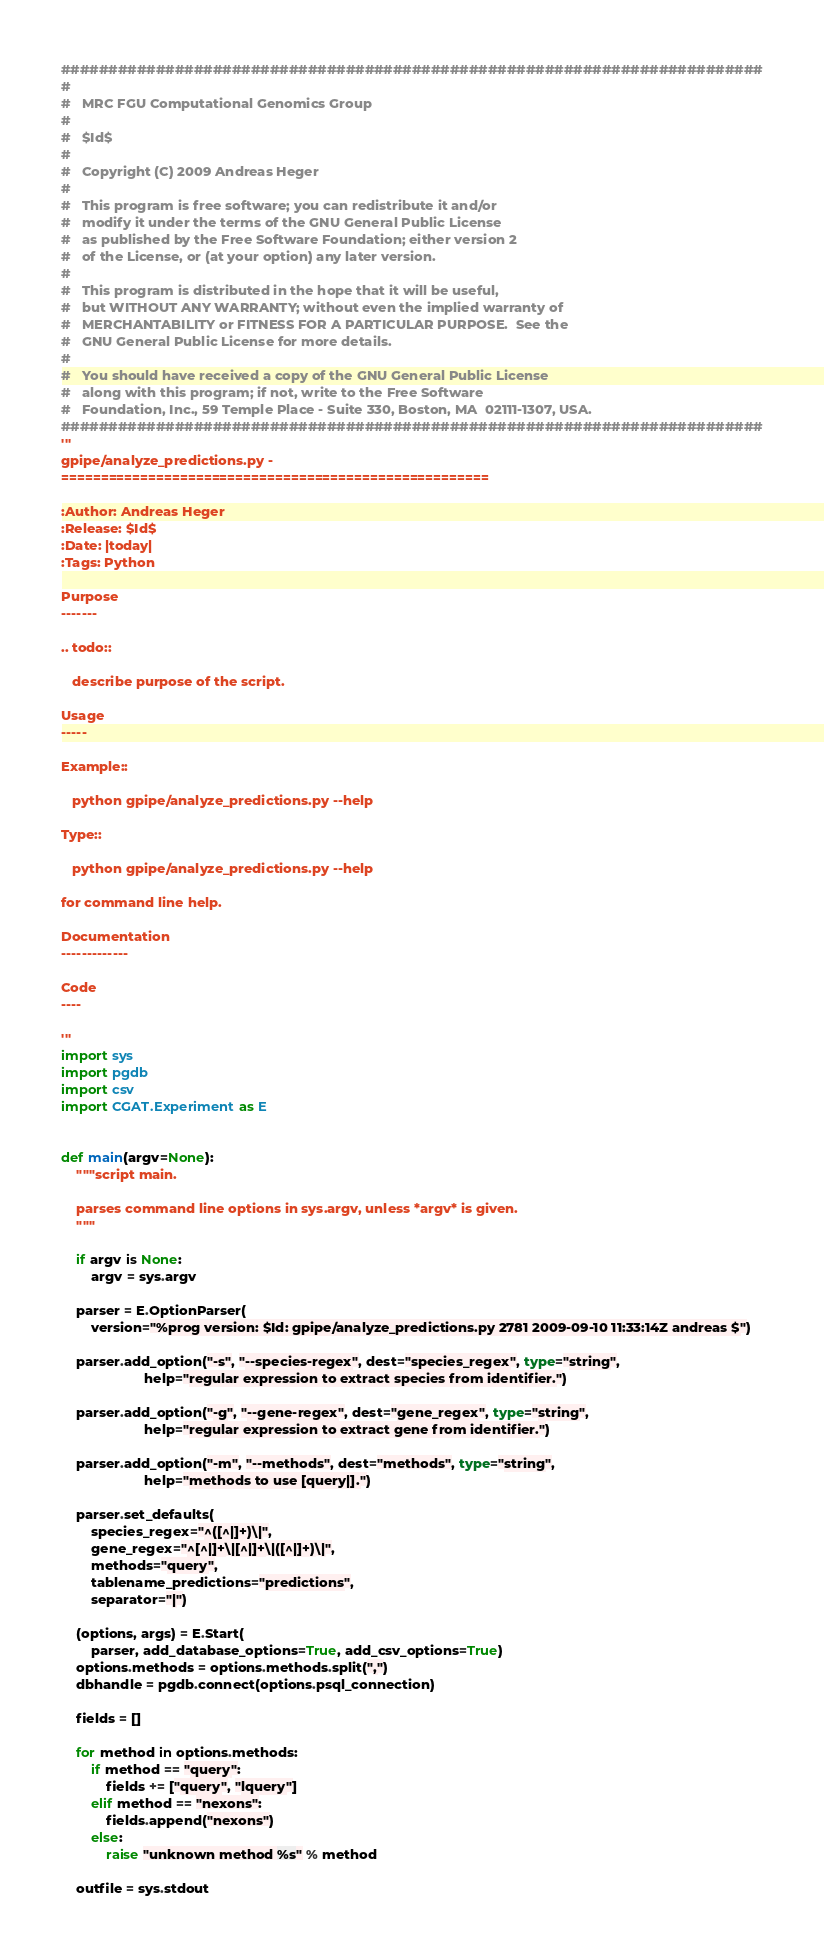<code> <loc_0><loc_0><loc_500><loc_500><_Python_>##########################################################################
#
#   MRC FGU Computational Genomics Group
#
#   $Id$
#
#   Copyright (C) 2009 Andreas Heger
#
#   This program is free software; you can redistribute it and/or
#   modify it under the terms of the GNU General Public License
#   as published by the Free Software Foundation; either version 2
#   of the License, or (at your option) any later version.
#
#   This program is distributed in the hope that it will be useful,
#   but WITHOUT ANY WARRANTY; without even the implied warranty of
#   MERCHANTABILITY or FITNESS FOR A PARTICULAR PURPOSE.  See the
#   GNU General Public License for more details.
#
#   You should have received a copy of the GNU General Public License
#   along with this program; if not, write to the Free Software
#   Foundation, Inc., 59 Temple Place - Suite 330, Boston, MA  02111-1307, USA.
##########################################################################
'''
gpipe/analyze_predictions.py - 
======================================================

:Author: Andreas Heger
:Release: $Id$
:Date: |today|
:Tags: Python

Purpose
-------

.. todo::
   
   describe purpose of the script.

Usage
-----

Example::

   python gpipe/analyze_predictions.py --help

Type::

   python gpipe/analyze_predictions.py --help

for command line help.

Documentation
-------------

Code
----

'''
import sys
import pgdb
import csv
import CGAT.Experiment as E


def main(argv=None):
    """script main.

    parses command line options in sys.argv, unless *argv* is given.
    """

    if argv is None:
        argv = sys.argv

    parser = E.OptionParser(
        version="%prog version: $Id: gpipe/analyze_predictions.py 2781 2009-09-10 11:33:14Z andreas $")

    parser.add_option("-s", "--species-regex", dest="species_regex", type="string",
                      help="regular expression to extract species from identifier.")

    parser.add_option("-g", "--gene-regex", dest="gene_regex", type="string",
                      help="regular expression to extract gene from identifier.")

    parser.add_option("-m", "--methods", dest="methods", type="string",
                      help="methods to use [query|].")

    parser.set_defaults(
        species_regex="^([^|]+)\|",
        gene_regex="^[^|]+\|[^|]+\|([^|]+)\|",
        methods="query",
        tablename_predictions="predictions",
        separator="|")

    (options, args) = E.Start(
        parser, add_database_options=True, add_csv_options=True)
    options.methods = options.methods.split(",")
    dbhandle = pgdb.connect(options.psql_connection)

    fields = []

    for method in options.methods:
        if method == "query":
            fields += ["query", "lquery"]
        elif method == "nexons":
            fields.append("nexons")
        else:
            raise "unknown method %s" % method

    outfile = sys.stdout</code> 